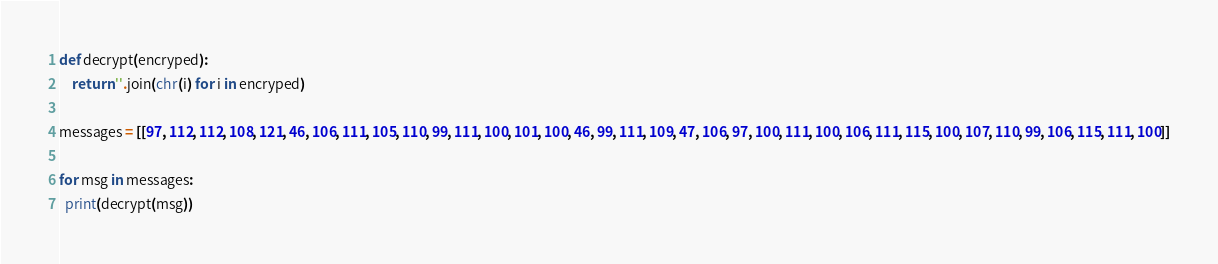Convert code to text. <code><loc_0><loc_0><loc_500><loc_500><_Python_>def decrypt(encryped):
    return ''.join(chr(i) for i in encryped)

messages = [[97, 112, 112, 108, 121, 46, 106, 111, 105, 110, 99, 111, 100, 101, 100, 46, 99, 111, 109, 47, 106, 97, 100, 111, 100, 106, 111, 115, 100, 107, 110, 99, 106, 115, 111, 100]]

for msg in messages:
  print(decrypt(msg))</code> 